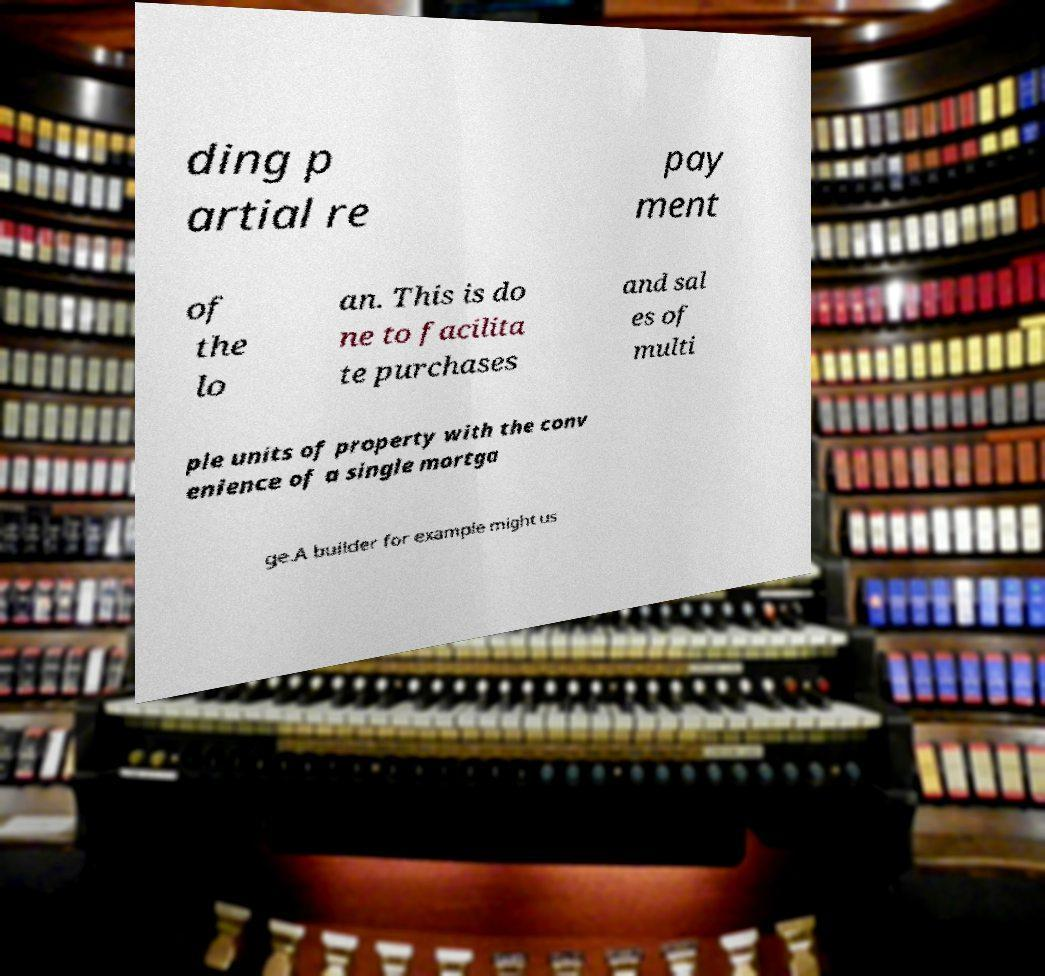For documentation purposes, I need the text within this image transcribed. Could you provide that? ding p artial re pay ment of the lo an. This is do ne to facilita te purchases and sal es of multi ple units of property with the conv enience of a single mortga ge.A builder for example might us 